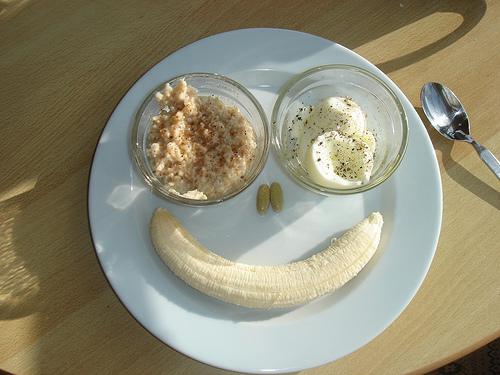What is the fruit on the bottom of the plate?
Write a very short answer. Banana. What color is the plate?
Keep it brief. White. Is there a face in the picture?
Write a very short answer. Yes. 